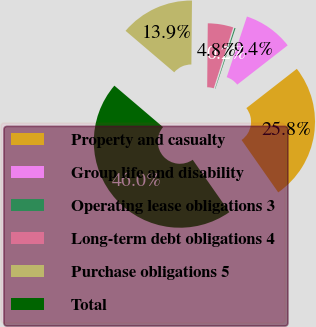Convert chart to OTSL. <chart><loc_0><loc_0><loc_500><loc_500><pie_chart><fcel>Property and casualty<fcel>Group life and disability<fcel>Operating lease obligations 3<fcel>Long-term debt obligations 4<fcel>Purchase obligations 5<fcel>Total<nl><fcel>25.81%<fcel>9.35%<fcel>0.2%<fcel>4.77%<fcel>13.92%<fcel>45.95%<nl></chart> 